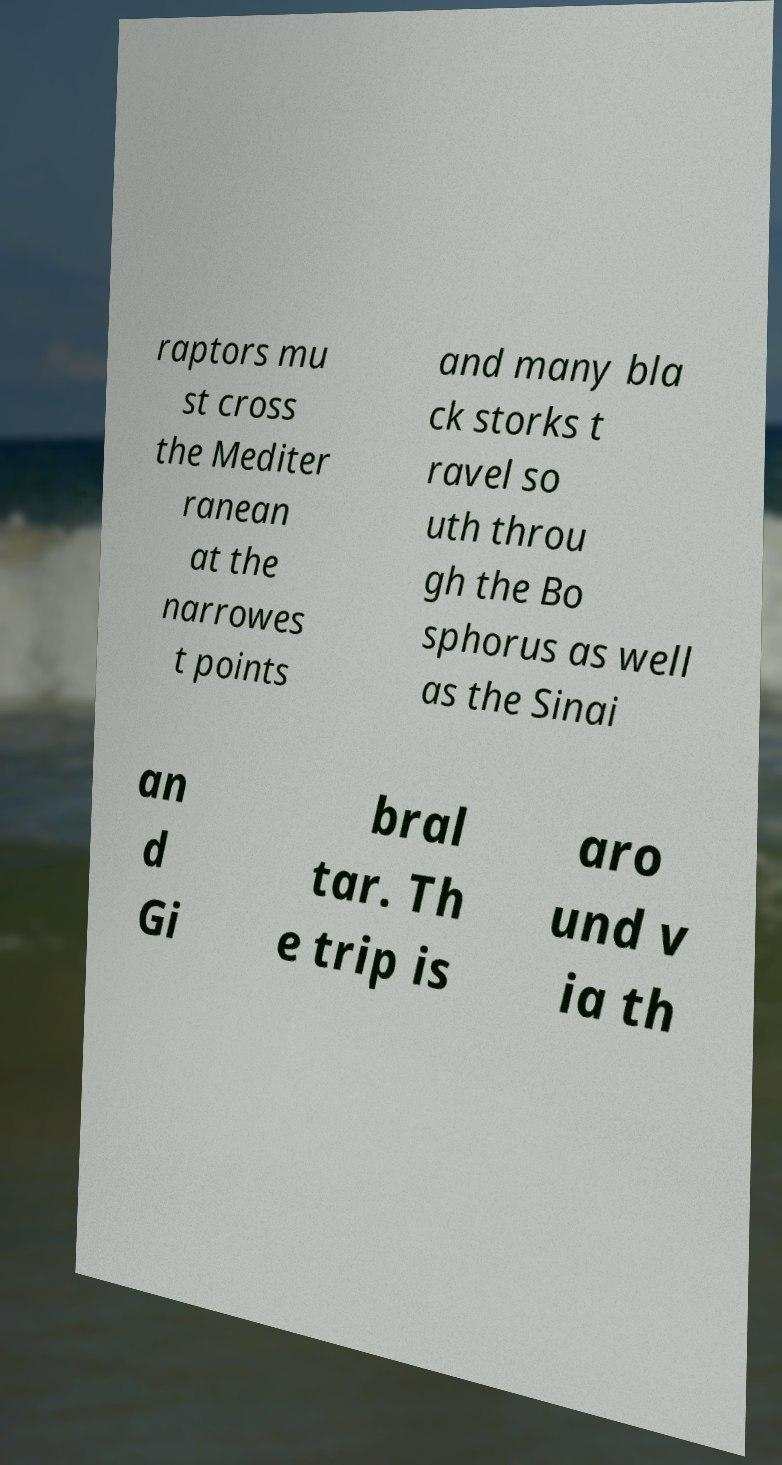Can you read and provide the text displayed in the image?This photo seems to have some interesting text. Can you extract and type it out for me? raptors mu st cross the Mediter ranean at the narrowes t points and many bla ck storks t ravel so uth throu gh the Bo sphorus as well as the Sinai an d Gi bral tar. Th e trip is aro und v ia th 